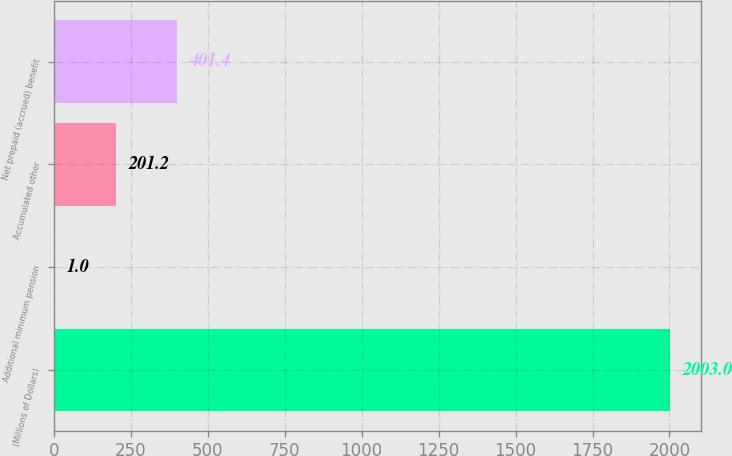<chart> <loc_0><loc_0><loc_500><loc_500><bar_chart><fcel>(Millions of Dollars)<fcel>Additional minimum pension<fcel>Accumulated other<fcel>Net prepaid (accrued) benefit<nl><fcel>2003<fcel>1<fcel>201.2<fcel>401.4<nl></chart> 